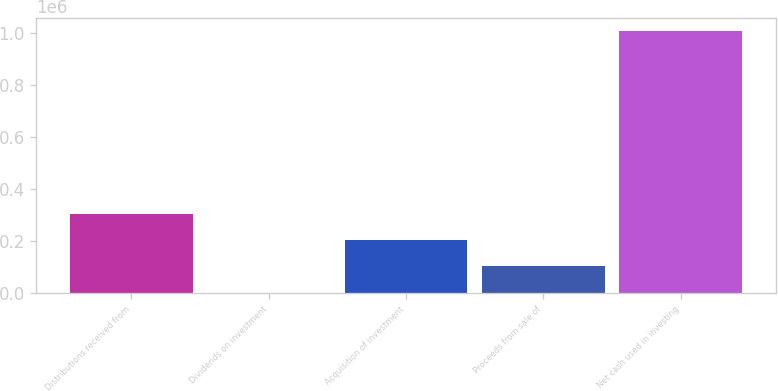Convert chart. <chart><loc_0><loc_0><loc_500><loc_500><bar_chart><fcel>Distributions received from<fcel>Dividends on investment<fcel>Acquisition of investment<fcel>Proceeds from sale of<fcel>Net cash used in investing<nl><fcel>302424<fcel>365<fcel>201738<fcel>101052<fcel>1.00723e+06<nl></chart> 